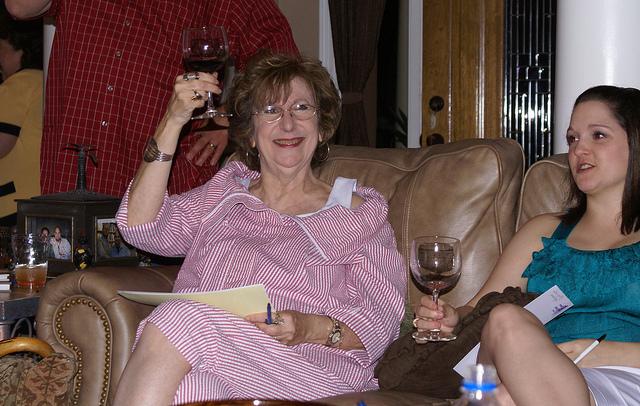Red or white wine?
Concise answer only. Red. Are these ladies drinking from a wine glass?
Give a very brief answer. Yes. Is this a restaurant?
Keep it brief. No. What kind of decor is on the arm of the couch?
Keep it brief. Rivets. 